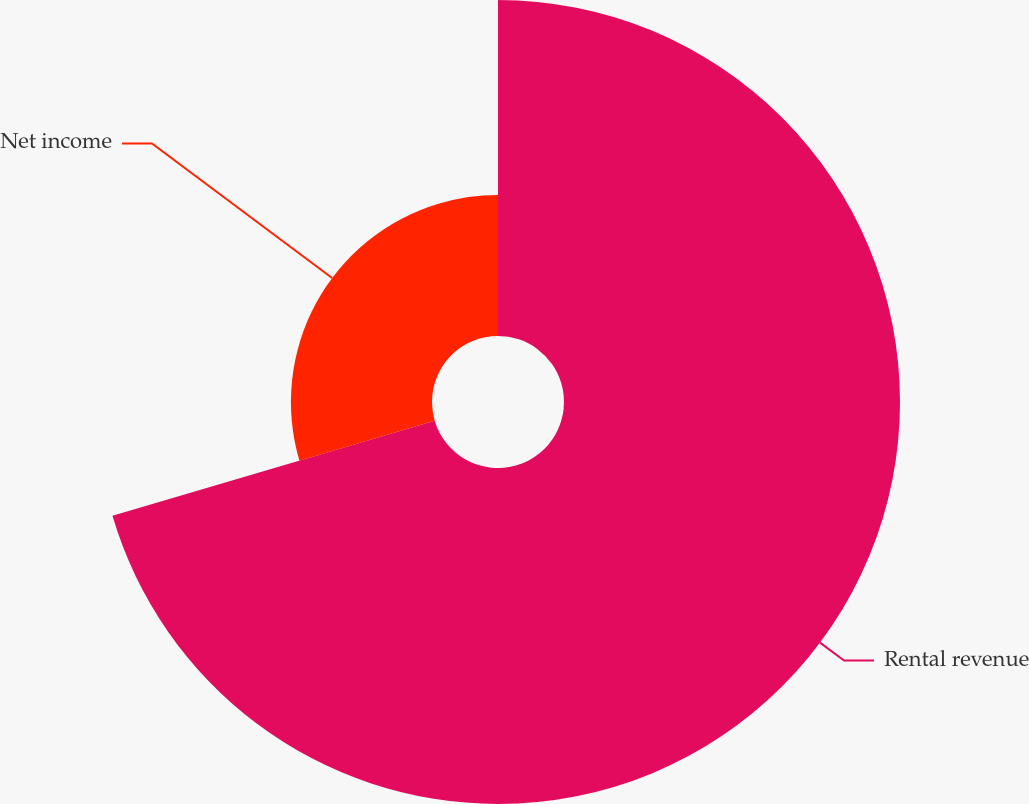Convert chart to OTSL. <chart><loc_0><loc_0><loc_500><loc_500><pie_chart><fcel>Rental revenue<fcel>Net income<nl><fcel>70.43%<fcel>29.57%<nl></chart> 